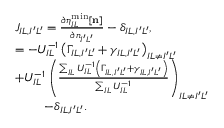Convert formula to latex. <formula><loc_0><loc_0><loc_500><loc_500>\begin{array} { r l } & { J _ { I L , I ^ { \prime } L ^ { \prime } } = \frac { \partial \eta _ { I L } ^ { \min } [ { n } ] } { \partial n _ { I ^ { \prime } L ^ { \prime } } } - \delta _ { I L , I ^ { \prime } L ^ { \prime } } , } \\ & { = - U _ { I L } ^ { - 1 } \left ( \Gamma _ { I L , I ^ { \prime } L ^ { \prime } } + \gamma _ { I L , I ^ { \prime } L ^ { \prime } } \right ) _ { I L \ne I ^ { \prime } L ^ { \prime } } } \\ & { + U _ { I L } ^ { - 1 } \left ( \frac { \sum _ { I L } U _ { I L } ^ { - 1 } \left ( \Gamma _ { I L , I ^ { \prime } L ^ { \prime } } + \gamma _ { I L , I ^ { \prime } L ^ { \prime } } \right ) } { \sum _ { I L } U _ { I L } ^ { - 1 } } \right ) _ { I L \ne I ^ { \prime } L ^ { \prime } } } \\ & { - \delta _ { I L , I ^ { \prime } L ^ { \prime } } . } \end{array}</formula> 